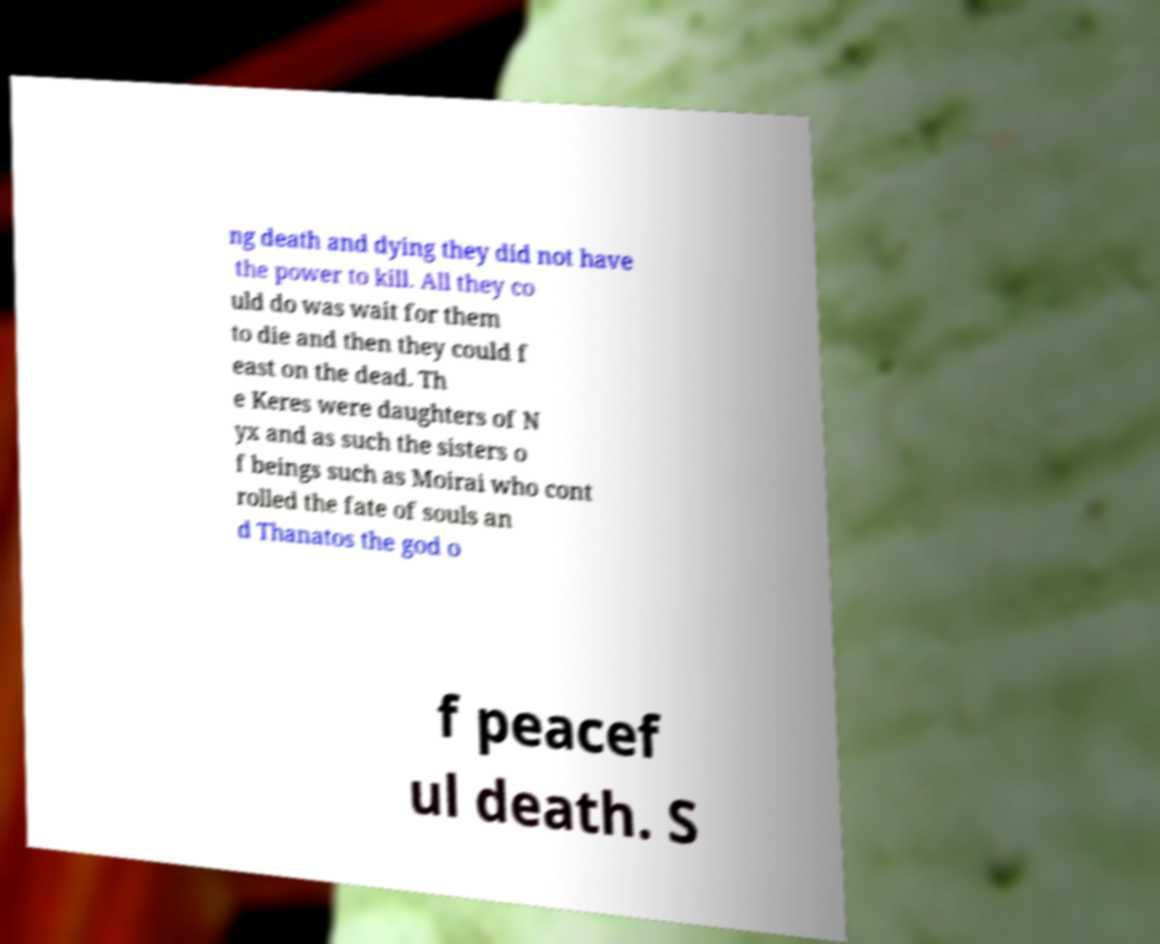Can you read and provide the text displayed in the image?This photo seems to have some interesting text. Can you extract and type it out for me? ng death and dying they did not have the power to kill. All they co uld do was wait for them to die and then they could f east on the dead. Th e Keres were daughters of N yx and as such the sisters o f beings such as Moirai who cont rolled the fate of souls an d Thanatos the god o f peacef ul death. S 